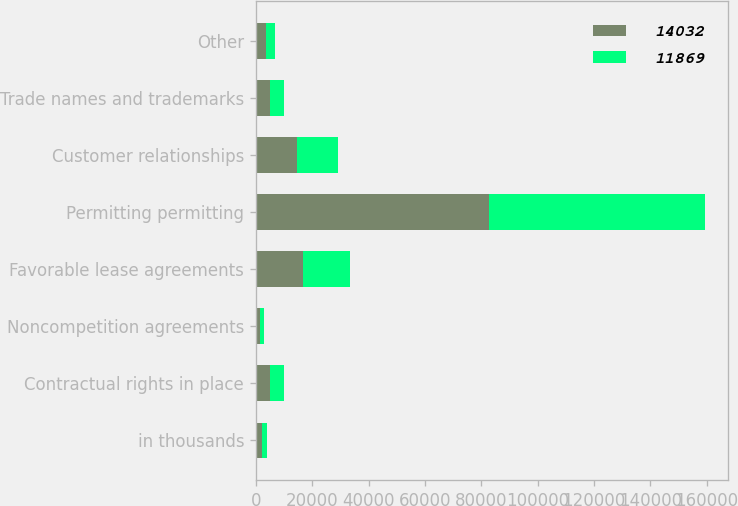Convert chart to OTSL. <chart><loc_0><loc_0><loc_500><loc_500><stacked_bar_chart><ecel><fcel>in thousands<fcel>Contractual rights in place<fcel>Noncompetition agreements<fcel>Favorable lease agreements<fcel>Permitting permitting<fcel>Customer relationships<fcel>Trade names and trademarks<fcel>Other<nl><fcel>14032<fcel>2012<fcel>5006<fcel>1450<fcel>16677<fcel>82596<fcel>14493<fcel>5006<fcel>3711<nl><fcel>11869<fcel>2011<fcel>5006<fcel>1430<fcel>16677<fcel>76956<fcel>14493<fcel>5006<fcel>3200<nl></chart> 